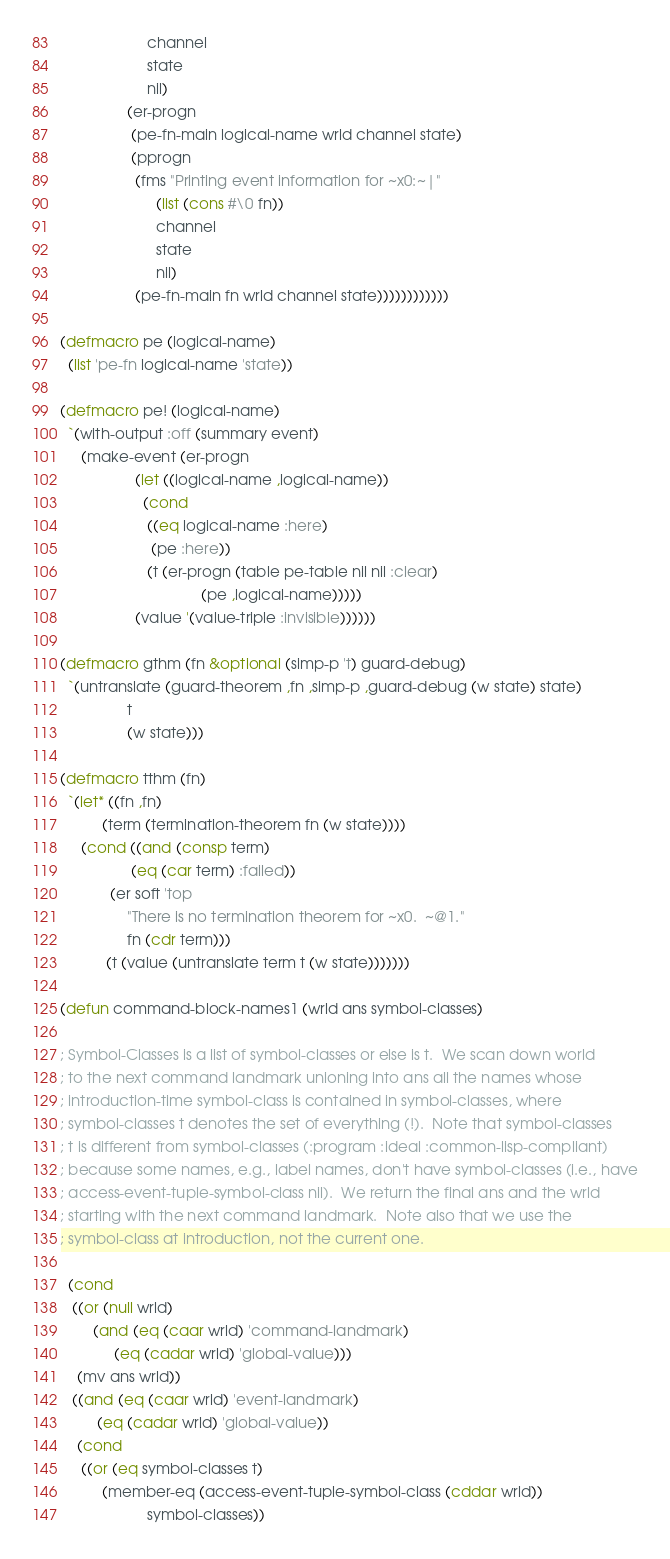<code> <loc_0><loc_0><loc_500><loc_500><_Lisp_>                     channel
                     state
                     nil)
                (er-progn
                 (pe-fn-main logical-name wrld channel state)
                 (pprogn
                  (fms "Printing event information for ~x0:~|"
                       (list (cons #\0 fn))
                       channel
                       state
                       nil)
                  (pe-fn-main fn wrld channel state))))))))))))

(defmacro pe (logical-name)
  (list 'pe-fn logical-name 'state))

(defmacro pe! (logical-name)
  `(with-output :off (summary event)
     (make-event (er-progn
                  (let ((logical-name ,logical-name))
                    (cond
                     ((eq logical-name :here)
                      (pe :here))
                     (t (er-progn (table pe-table nil nil :clear)
                                  (pe ,logical-name)))))
                  (value '(value-triple :invisible))))))

(defmacro gthm (fn &optional (simp-p 't) guard-debug)
  `(untranslate (guard-theorem ,fn ,simp-p ,guard-debug (w state) state)
                t
                (w state)))

(defmacro tthm (fn)
  `(let* ((fn ,fn)
          (term (termination-theorem fn (w state))))
     (cond ((and (consp term)
                 (eq (car term) :failed))
            (er soft 'top
                "There is no termination theorem for ~x0.  ~@1."
                fn (cdr term)))
           (t (value (untranslate term t (w state)))))))

(defun command-block-names1 (wrld ans symbol-classes)

; Symbol-Classes is a list of symbol-classes or else is t.  We scan down world
; to the next command landmark unioning into ans all the names whose
; introduction-time symbol-class is contained in symbol-classes, where
; symbol-classes t denotes the set of everything (!).  Note that symbol-classes
; t is different from symbol-classes (:program :ideal :common-lisp-compliant)
; because some names, e.g., label names, don't have symbol-classes (i.e., have
; access-event-tuple-symbol-class nil).  We return the final ans and the wrld
; starting with the next command landmark.  Note also that we use the
; symbol-class at introduction, not the current one.

  (cond
   ((or (null wrld)
        (and (eq (caar wrld) 'command-landmark)
             (eq (cadar wrld) 'global-value)))
    (mv ans wrld))
   ((and (eq (caar wrld) 'event-landmark)
         (eq (cadar wrld) 'global-value))
    (cond
     ((or (eq symbol-classes t)
          (member-eq (access-event-tuple-symbol-class (cddar wrld))
                     symbol-classes))</code> 